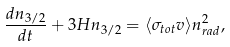Convert formula to latex. <formula><loc_0><loc_0><loc_500><loc_500>\frac { d n _ { 3 / 2 } } { d t } + 3 H n _ { 3 / 2 } = \langle \sigma _ { t o t } v \rangle n _ { r a d } ^ { 2 } ,</formula> 